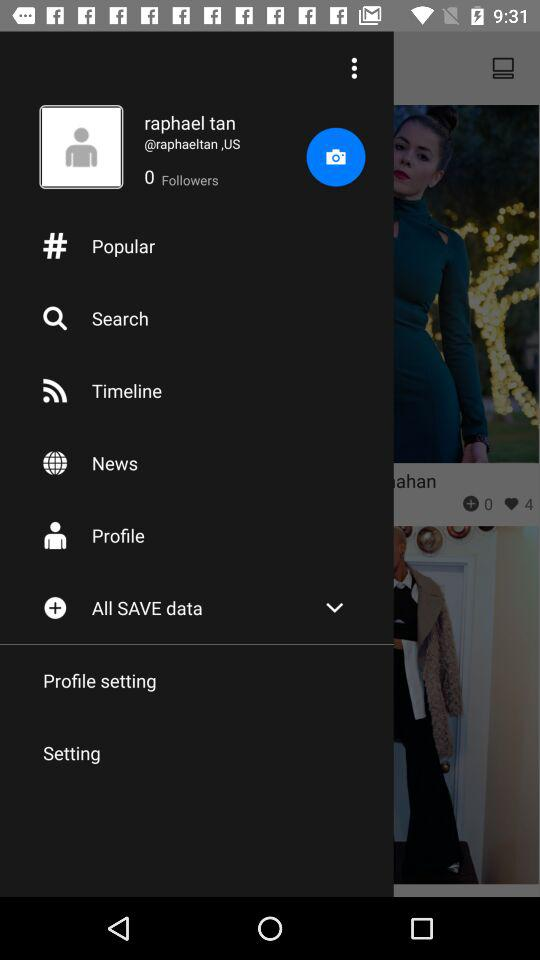What is the name of the user? The name of the user is Raphael Tan. 